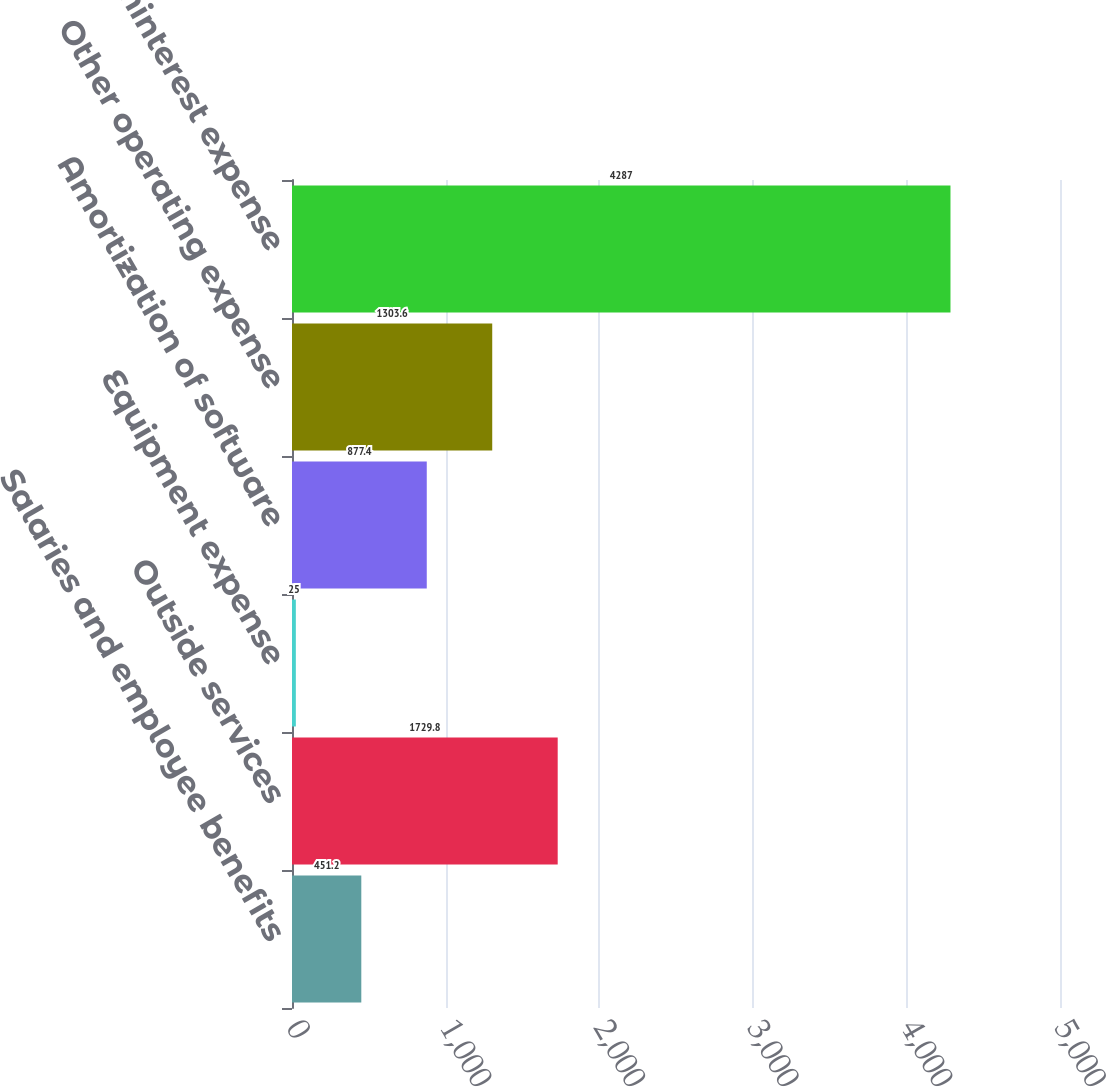Convert chart to OTSL. <chart><loc_0><loc_0><loc_500><loc_500><bar_chart><fcel>Salaries and employee benefits<fcel>Outside services<fcel>Equipment expense<fcel>Amortization of software<fcel>Other operating expense<fcel>Noninterest expense<nl><fcel>451.2<fcel>1729.8<fcel>25<fcel>877.4<fcel>1303.6<fcel>4287<nl></chart> 